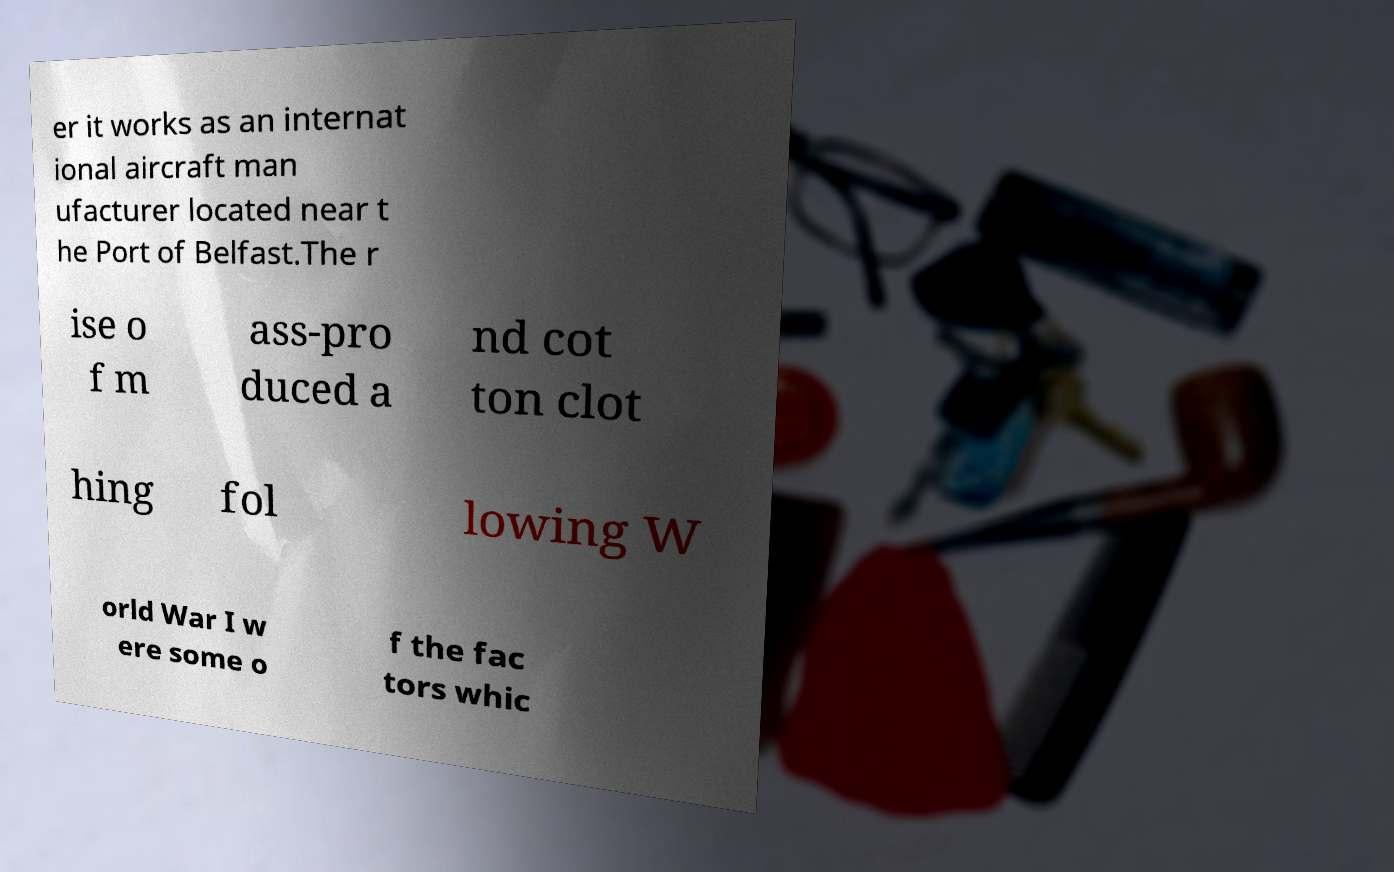Can you read and provide the text displayed in the image?This photo seems to have some interesting text. Can you extract and type it out for me? er it works as an internat ional aircraft man ufacturer located near t he Port of Belfast.The r ise o f m ass-pro duced a nd cot ton clot hing fol lowing W orld War I w ere some o f the fac tors whic 